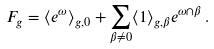<formula> <loc_0><loc_0><loc_500><loc_500>F _ { g } = \langle e ^ { \omega } \rangle _ { g , 0 } + \sum _ { \beta \not = 0 } \langle 1 \rangle _ { g , \beta } e ^ { \omega \cap \beta } \, .</formula> 